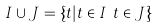<formula> <loc_0><loc_0><loc_500><loc_500>I \cup J = \{ t | t \in I \lor t \in J \}</formula> 